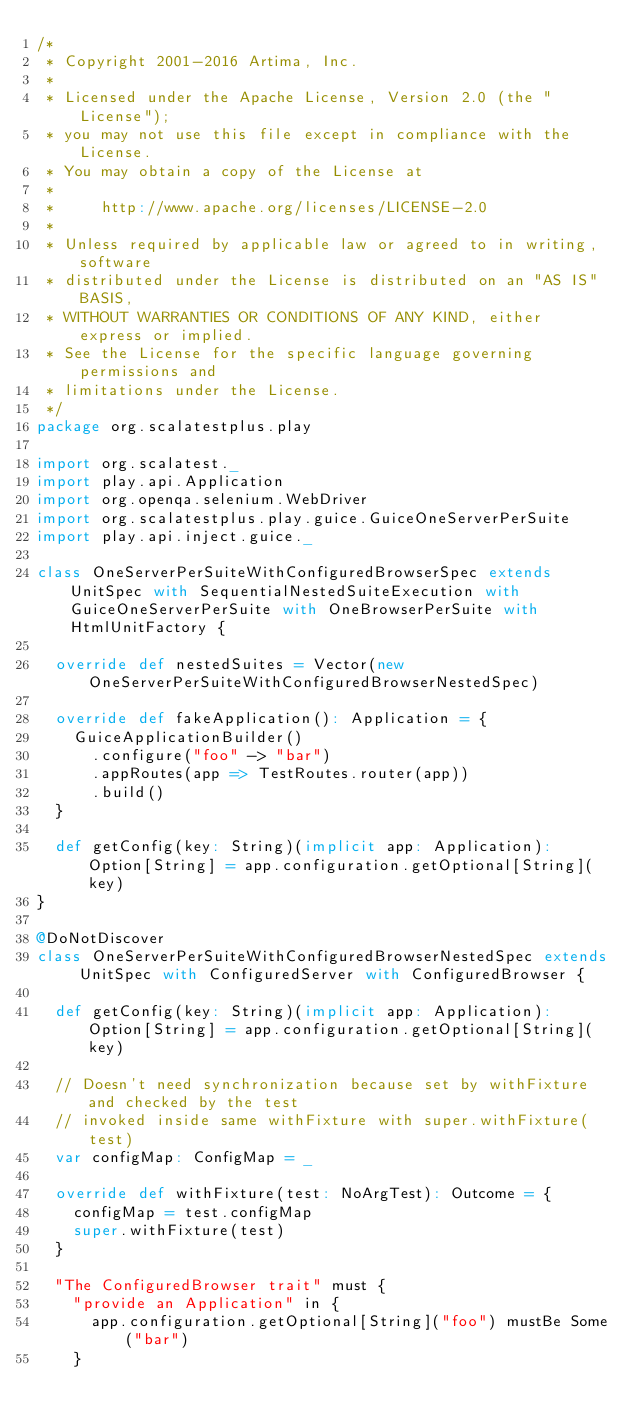<code> <loc_0><loc_0><loc_500><loc_500><_Scala_>/*
 * Copyright 2001-2016 Artima, Inc.
 *
 * Licensed under the Apache License, Version 2.0 (the "License");
 * you may not use this file except in compliance with the License.
 * You may obtain a copy of the License at
 *
 *     http://www.apache.org/licenses/LICENSE-2.0
 *
 * Unless required by applicable law or agreed to in writing, software
 * distributed under the License is distributed on an "AS IS" BASIS,
 * WITHOUT WARRANTIES OR CONDITIONS OF ANY KIND, either express or implied.
 * See the License for the specific language governing permissions and
 * limitations under the License.
 */
package org.scalatestplus.play

import org.scalatest._
import play.api.Application
import org.openqa.selenium.WebDriver
import org.scalatestplus.play.guice.GuiceOneServerPerSuite
import play.api.inject.guice._

class OneServerPerSuiteWithConfiguredBrowserSpec extends UnitSpec with SequentialNestedSuiteExecution with GuiceOneServerPerSuite with OneBrowserPerSuite with HtmlUnitFactory {

  override def nestedSuites = Vector(new OneServerPerSuiteWithConfiguredBrowserNestedSpec)

  override def fakeApplication(): Application = {
    GuiceApplicationBuilder()
      .configure("foo" -> "bar")
      .appRoutes(app => TestRoutes.router(app))
      .build()
  }

  def getConfig(key: String)(implicit app: Application): Option[String] = app.configuration.getOptional[String](key)
}

@DoNotDiscover
class OneServerPerSuiteWithConfiguredBrowserNestedSpec extends UnitSpec with ConfiguredServer with ConfiguredBrowser {

  def getConfig(key: String)(implicit app: Application): Option[String] = app.configuration.getOptional[String](key)

  // Doesn't need synchronization because set by withFixture and checked by the test
  // invoked inside same withFixture with super.withFixture(test)
  var configMap: ConfigMap = _

  override def withFixture(test: NoArgTest): Outcome = {
    configMap = test.configMap
    super.withFixture(test)
  }

  "The ConfiguredBrowser trait" must {
    "provide an Application" in {
      app.configuration.getOptional[String]("foo") mustBe Some("bar")
    }</code> 